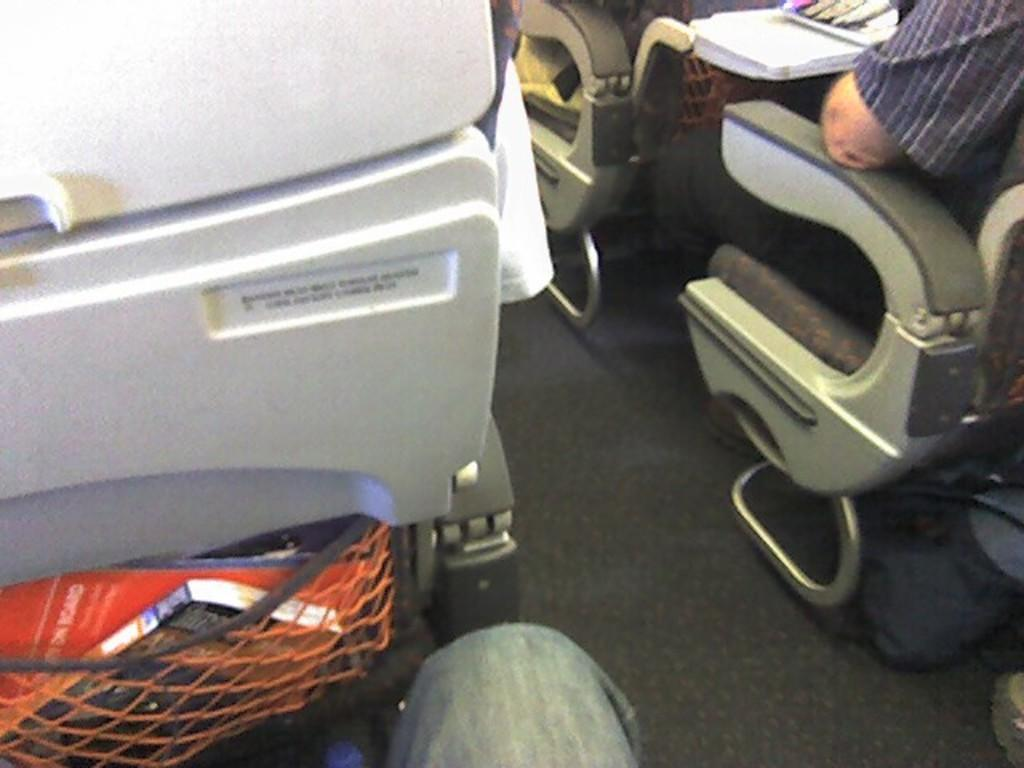What is happening in the image? There is a group of people in the image, and they are seated on chairs. Can you describe the setting in the image? The people are seated on chairs, and there is a book on the left side of the image. What type of bears can be seen sailing in the image? There are no bears or sailing activities present in the image. 